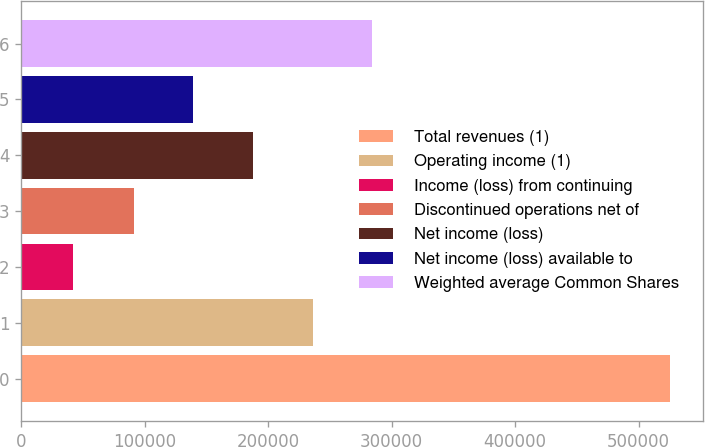<chart> <loc_0><loc_0><loc_500><loc_500><bar_chart><fcel>Total revenues (1)<fcel>Operating income (1)<fcel>Income (loss) from continuing<fcel>Discontinued operations net of<fcel>Net income (loss)<fcel>Net income (loss) available to<fcel>Weighted average Common Shares<nl><fcel>525601<fcel>235960<fcel>41794<fcel>90818<fcel>187579<fcel>139199<fcel>284341<nl></chart> 